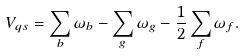Convert formula to latex. <formula><loc_0><loc_0><loc_500><loc_500>V _ { q s } = \sum _ { b } \omega _ { b } - \sum _ { g } \omega _ { g } - \frac { 1 } { 2 } \sum _ { f } \omega _ { f } .</formula> 